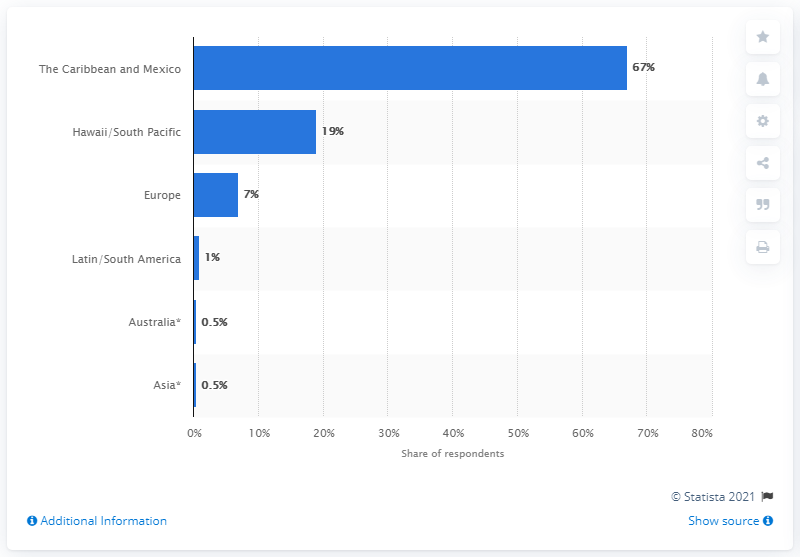Mention a couple of crucial points in this snapshot. According to a survey conducted by travel agents in 2014, 7% of their clients chose to honeymoon in Europe. 